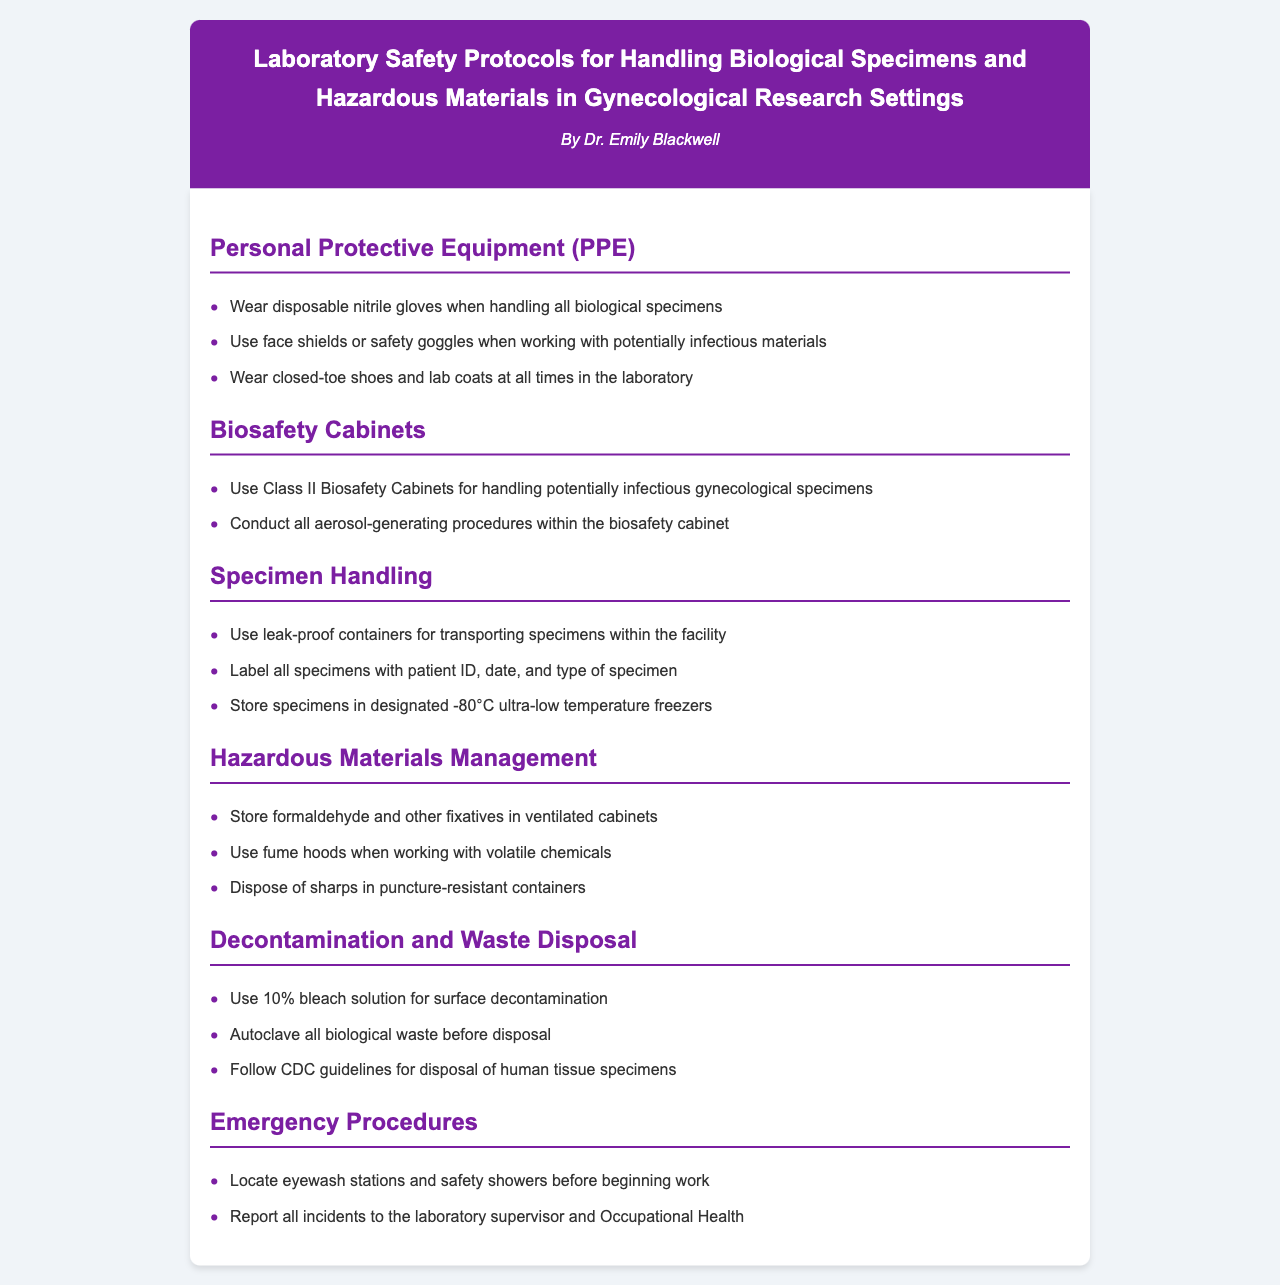What is the title of the document? The title of the document is presented in the header section, which indicates the focus on laboratory safety protocols.
Answer: Laboratory Safety Protocols for Handling Biological Specimens and Hazardous Materials in Gynecological Research Settings Who is the author of the document? The author's name is included below the title in the header section, identifying the individual responsible for the content.
Answer: Dr. Emily Blackwell What type of PPE is recommended when handling biological specimens? The document specifies the required personal protective equipment in the PPE section, highlighting the need for gloves.
Answer: Disposable nitrile gloves What temperature should gynecological specimens be stored at? The Specimen Handling section provides guidelines on the storage conditions for specimens, specifying the appropriate temperature.
Answer: -80°C What is the disposal method for biological waste mentioned in the document? The Decontamination and Waste Disposal section outlines the proper disposal process for biological waste, emphasizing a specific method.
Answer: Autoclave all biological waste What special equipment is required for handling potentially infectious specimens? The Biosafety Cabinets section mentions the type of equipment needed for the safe handling of infectious materials in gynecological research.
Answer: Class II Biosafety Cabinets What should be done with sharps after use? The Hazardous Materials Management section provides specific instructions for the disposal of sharp materials, indicating the type of container needed.
Answer: Puncture-resistant containers What solution is suggested for surface decontamination? The Decontamination and Waste Disposal section specifies a particular solution used for cleaning surfaces in the laboratory.
Answer: 10% bleach solution What action should be taken following an incident in the laboratory? The Emergency Procedures section describes the necessary steps to be taken after an incident occurs in the lab environment.
Answer: Report all incidents to the laboratory supervisor and Occupational Health 